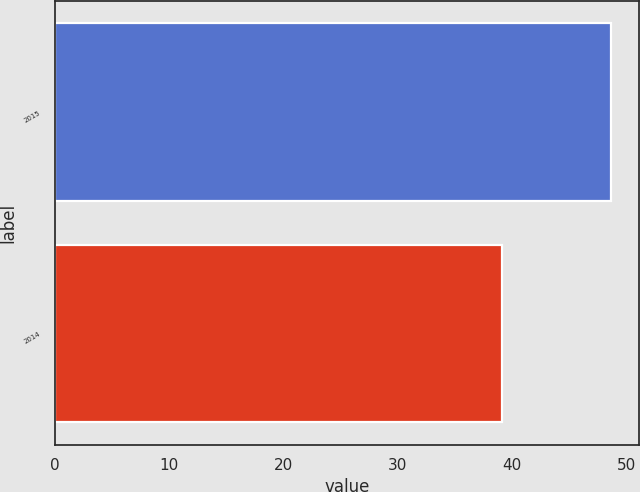Convert chart to OTSL. <chart><loc_0><loc_0><loc_500><loc_500><bar_chart><fcel>2015<fcel>2014<nl><fcel>48.66<fcel>39.11<nl></chart> 